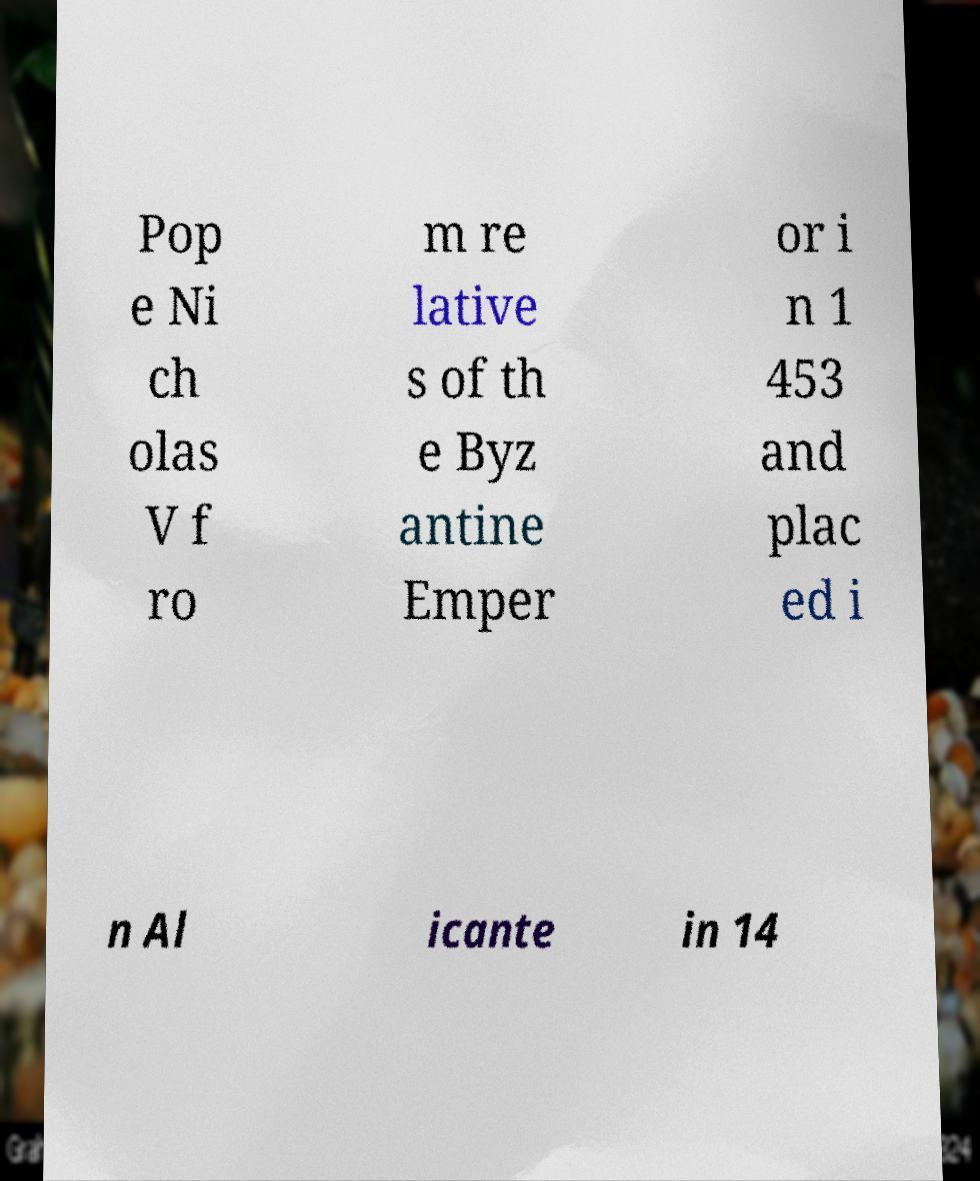What messages or text are displayed in this image? I need them in a readable, typed format. Pop e Ni ch olas V f ro m re lative s of th e Byz antine Emper or i n 1 453 and plac ed i n Al icante in 14 